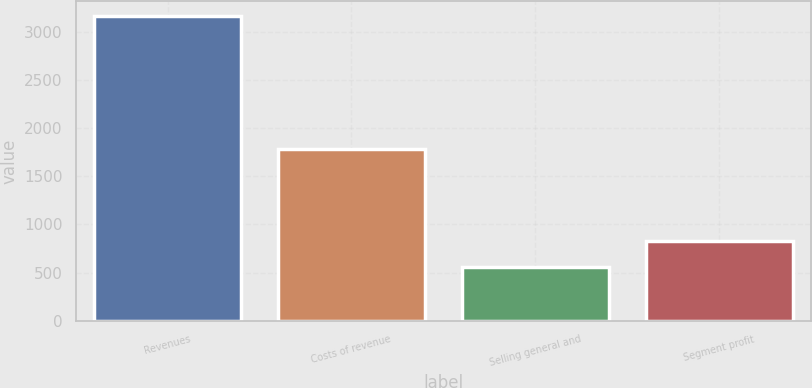Convert chart to OTSL. <chart><loc_0><loc_0><loc_500><loc_500><bar_chart><fcel>Revenues<fcel>Costs of revenue<fcel>Selling general and<fcel>Segment profit<nl><fcel>3159<fcel>1779<fcel>556<fcel>824<nl></chart> 